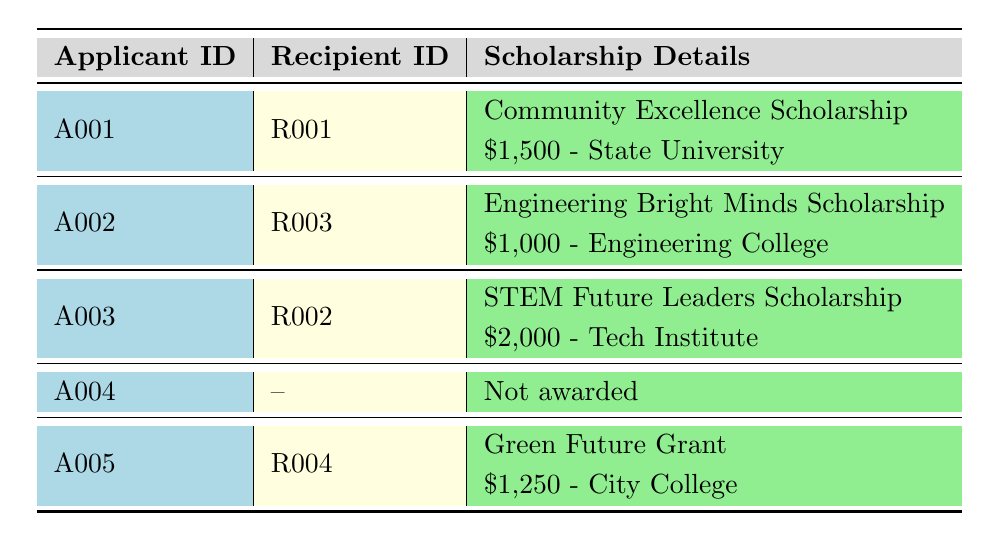What is the age of the youngest scholarship recipient? The youngest scholarship recipient is Michael Smith, who is 17 years old among all recipients listed in the table.
Answer: 17 How much financial support does Sara Kim receive? Sara Kim is awarded the STEM Future Leaders Scholarship which amounts to $2,000 as stated in the scholarship details.
Answer: $2,000 Is David Lee a scholarship recipient? David Lee is listed as an applicant in the table but has not been awarded any scholarship, indicated by a dash in the recipient ID column.
Answer: No What was the total amount awarded to scholarship recipients? The total amount awarded to the recipients can be calculated by adding the award amounts for each recipient: 1500 + 2000 + 1000 + 1250 = 5750.
Answer: $5,750 Which major did the scholarship recipient with the highest GPA intend to pursue? Sara Kim had the highest GPA of 4.0 and her intended major is Computer Science, based on the information provided for both applicants and recipients.
Answer: Computer Science How many applicants had community service hours greater than 100? From the applicants listed, Emily Johnson (150 hours), Sara Kim (200 hours), and Lara Patel (120 hours) had community service hours greater than 100. That totals to three applicants.
Answer: 3 Did any of the recipients have their scholarships awarded to attend more than one college? Each recipient is listed with a unique college for their scholarship, so no recipient had their scholarships awarded to attend more than one college at the same time.
Answer: No What is the average award amount of the scholarships given out? The average award amount is calculated by taking the total amount awarded ($5750) and dividing it by the number of recipients (4): 5750 / 4 = 1437.50.
Answer: $1,437.50 